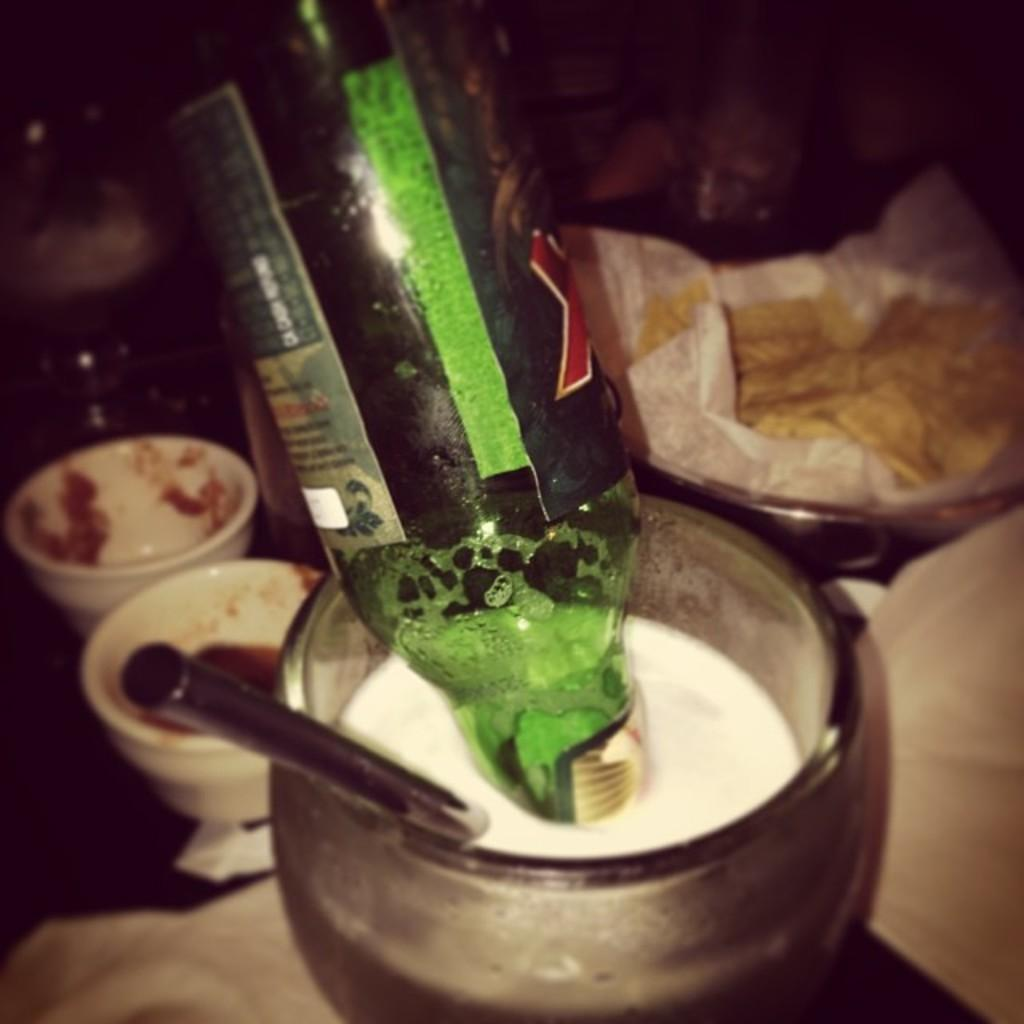What is inside the glass in the image? There is a straw and a bottle in the glass. What objects can be seen in the background of the image? There are two cups and a tissue in the background. What type of holiday is being celebrated in the image? There is no indication of a holiday being celebrated in the image. How many sugar cubes are visible in the image? There is no sugar present in the image. What type of bells can be heard ringing in the image? There is no sound, including bells, present in the image. 